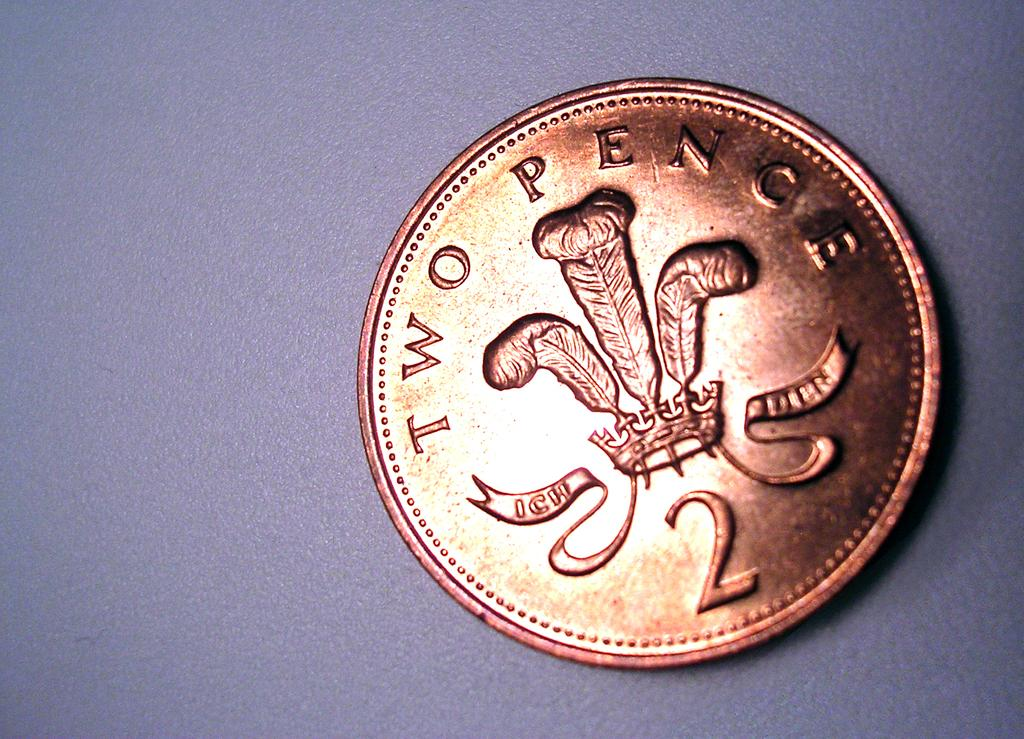<image>
Give a short and clear explanation of the subsequent image. The back of a two pence coin has an image of a crown with feathers engraved on it. 